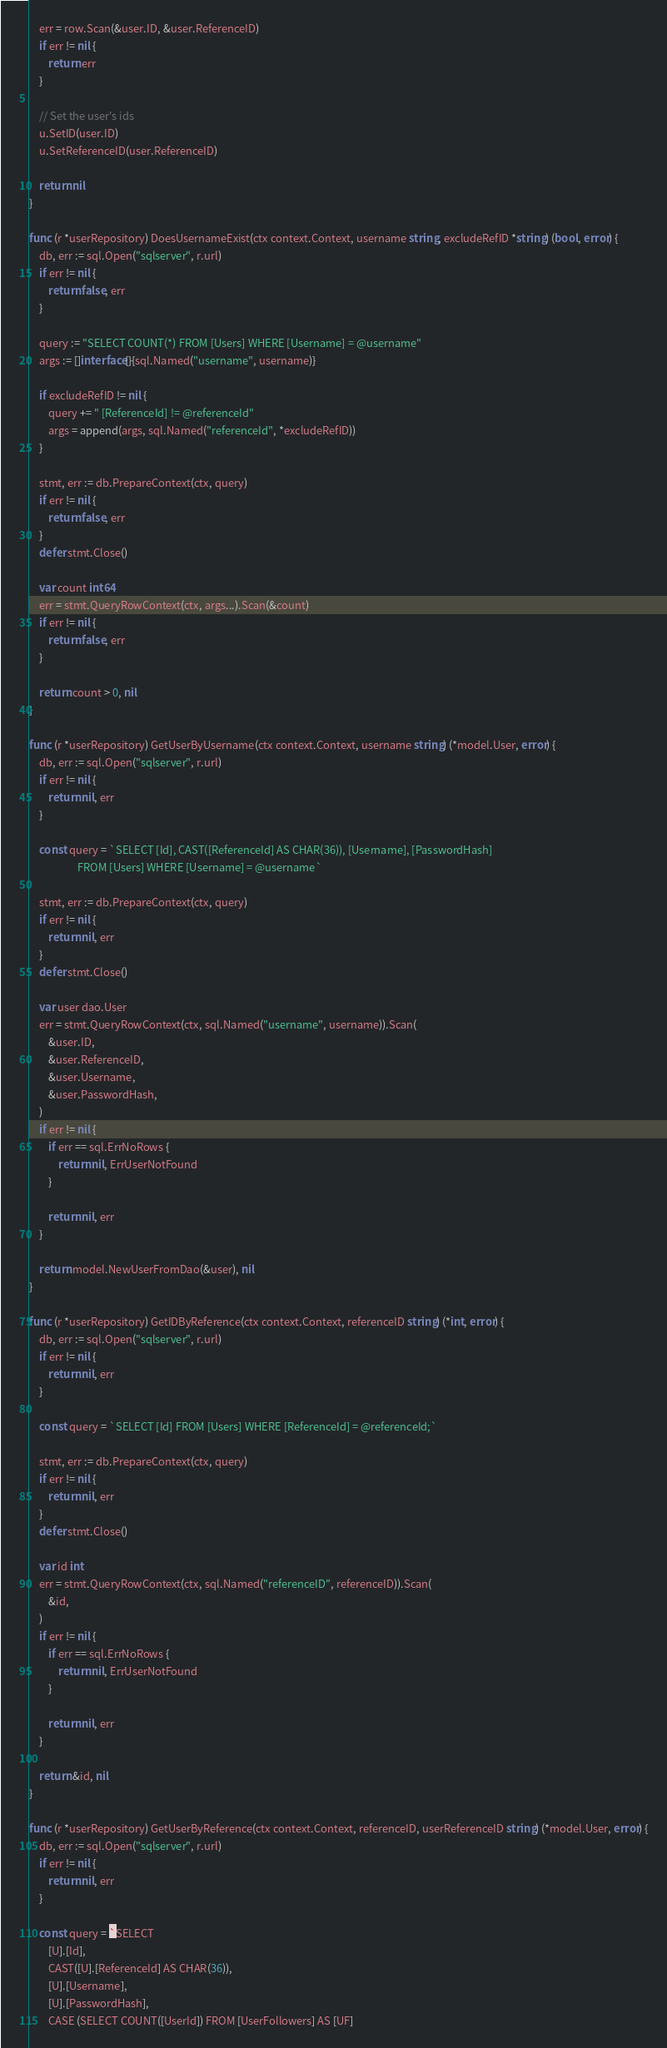<code> <loc_0><loc_0><loc_500><loc_500><_Go_>	err = row.Scan(&user.ID, &user.ReferenceID)
	if err != nil {
		return err
	}

	// Set the user's ids
	u.SetID(user.ID)
	u.SetReferenceID(user.ReferenceID)

	return nil
}

func (r *userRepository) DoesUsernameExist(ctx context.Context, username string, excludeRefID *string) (bool, error) {
	db, err := sql.Open("sqlserver", r.url)
	if err != nil {
		return false, err
	}

	query := "SELECT COUNT(*) FROM [Users] WHERE [Username] = @username"
	args := []interface{}{sql.Named("username", username)}

	if excludeRefID != nil {
		query += " [ReferenceId] != @referenceId"
		args = append(args, sql.Named("referenceId", *excludeRefID))
	}

	stmt, err := db.PrepareContext(ctx, query)
	if err != nil {
		return false, err
	}
	defer stmt.Close()

	var count int64
	err = stmt.QueryRowContext(ctx, args...).Scan(&count)
	if err != nil {
		return false, err
	}

	return count > 0, nil
}

func (r *userRepository) GetUserByUsername(ctx context.Context, username string) (*model.User, error) {
	db, err := sql.Open("sqlserver", r.url)
	if err != nil {
		return nil, err
	}

	const query = `SELECT [Id], CAST([ReferenceId] AS CHAR(36)), [Username], [PasswordHash]
					FROM [Users] WHERE [Username] = @username`

	stmt, err := db.PrepareContext(ctx, query)
	if err != nil {
		return nil, err
	}
	defer stmt.Close()

	var user dao.User
	err = stmt.QueryRowContext(ctx, sql.Named("username", username)).Scan(
		&user.ID,
		&user.ReferenceID,
		&user.Username,
		&user.PasswordHash,
	)
	if err != nil {
		if err == sql.ErrNoRows {
			return nil, ErrUserNotFound
		}

		return nil, err
	}

	return model.NewUserFromDao(&user), nil
}

func (r *userRepository) GetIDByReference(ctx context.Context, referenceID string) (*int, error) {
	db, err := sql.Open("sqlserver", r.url)
	if err != nil {
		return nil, err
	}

	const query = `SELECT [Id] FROM [Users] WHERE [ReferenceId] = @referenceId;`

	stmt, err := db.PrepareContext(ctx, query)
	if err != nil {
		return nil, err
	}
	defer stmt.Close()

	var id int
	err = stmt.QueryRowContext(ctx, sql.Named("referenceID", referenceID)).Scan(
		&id,
	)
	if err != nil {
		if err == sql.ErrNoRows {
			return nil, ErrUserNotFound
		}

		return nil, err
	}

	return &id, nil
}

func (r *userRepository) GetUserByReference(ctx context.Context, referenceID, userReferenceID string) (*model.User, error) {
	db, err := sql.Open("sqlserver", r.url)
	if err != nil {
		return nil, err
	}

	const query = `SELECT
		[U].[Id],
		CAST([U].[ReferenceId] AS CHAR(36)),
		[U].[Username],
		[U].[PasswordHash],
		CASE (SELECT COUNT([UserId]) FROM [UserFollowers] AS [UF]</code> 